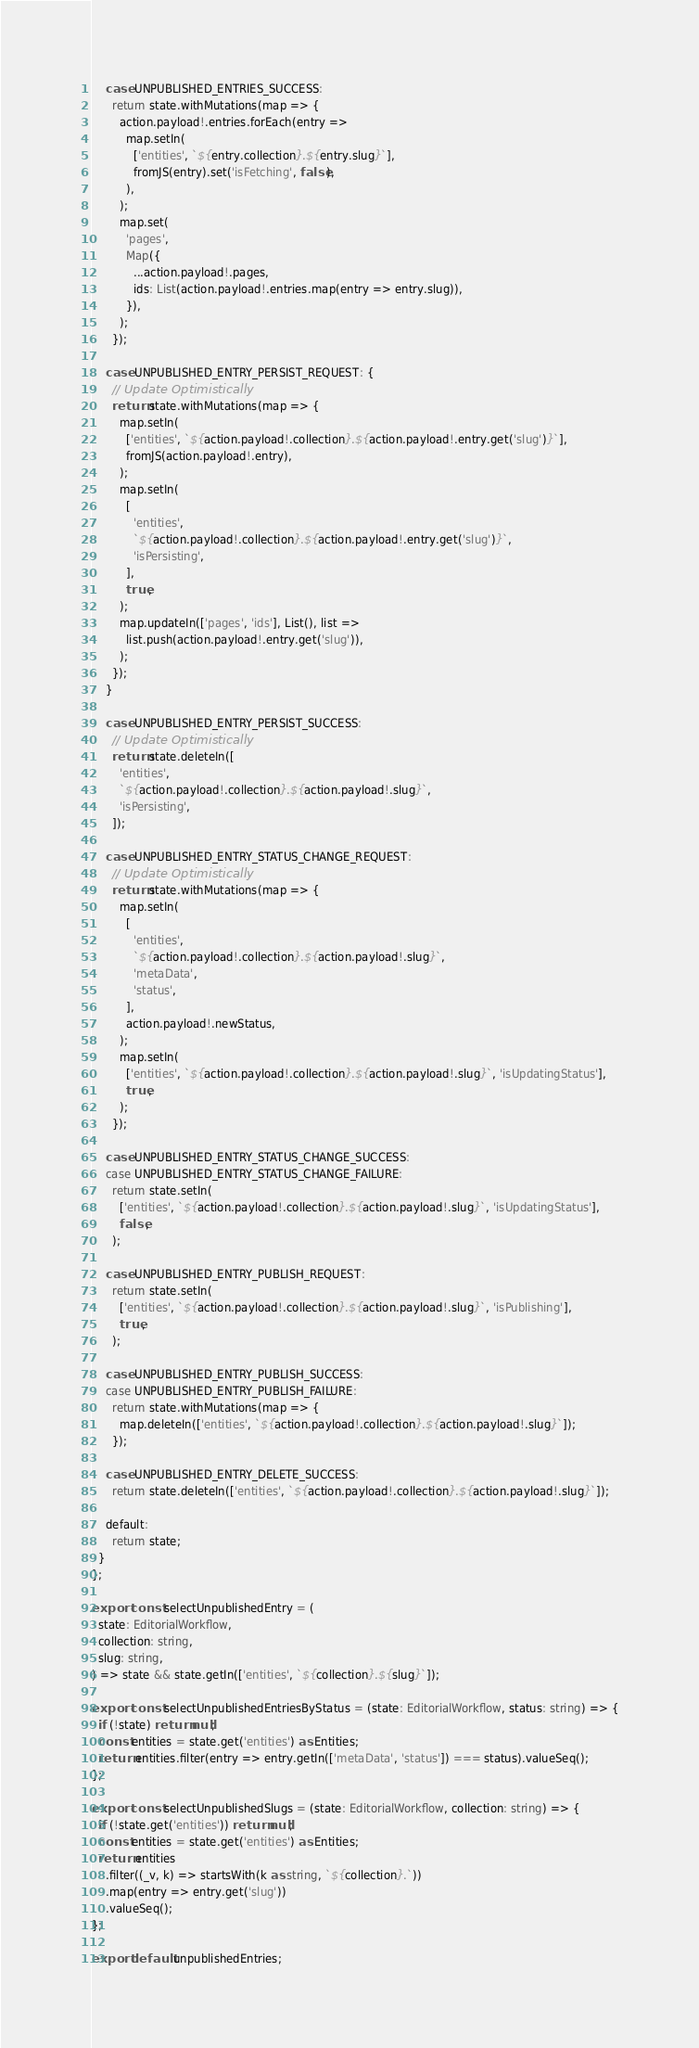Convert code to text. <code><loc_0><loc_0><loc_500><loc_500><_TypeScript_>
    case UNPUBLISHED_ENTRIES_SUCCESS:
      return state.withMutations(map => {
        action.payload!.entries.forEach(entry =>
          map.setIn(
            ['entities', `${entry.collection}.${entry.slug}`],
            fromJS(entry).set('isFetching', false),
          ),
        );
        map.set(
          'pages',
          Map({
            ...action.payload!.pages,
            ids: List(action.payload!.entries.map(entry => entry.slug)),
          }),
        );
      });

    case UNPUBLISHED_ENTRY_PERSIST_REQUEST: {
      // Update Optimistically
      return state.withMutations(map => {
        map.setIn(
          ['entities', `${action.payload!.collection}.${action.payload!.entry.get('slug')}`],
          fromJS(action.payload!.entry),
        );
        map.setIn(
          [
            'entities',
            `${action.payload!.collection}.${action.payload!.entry.get('slug')}`,
            'isPersisting',
          ],
          true,
        );
        map.updateIn(['pages', 'ids'], List(), list =>
          list.push(action.payload!.entry.get('slug')),
        );
      });
    }

    case UNPUBLISHED_ENTRY_PERSIST_SUCCESS:
      // Update Optimistically
      return state.deleteIn([
        'entities',
        `${action.payload!.collection}.${action.payload!.slug}`,
        'isPersisting',
      ]);

    case UNPUBLISHED_ENTRY_STATUS_CHANGE_REQUEST:
      // Update Optimistically
      return state.withMutations(map => {
        map.setIn(
          [
            'entities',
            `${action.payload!.collection}.${action.payload!.slug}`,
            'metaData',
            'status',
          ],
          action.payload!.newStatus,
        );
        map.setIn(
          ['entities', `${action.payload!.collection}.${action.payload!.slug}`, 'isUpdatingStatus'],
          true,
        );
      });

    case UNPUBLISHED_ENTRY_STATUS_CHANGE_SUCCESS:
    case UNPUBLISHED_ENTRY_STATUS_CHANGE_FAILURE:
      return state.setIn(
        ['entities', `${action.payload!.collection}.${action.payload!.slug}`, 'isUpdatingStatus'],
        false,
      );

    case UNPUBLISHED_ENTRY_PUBLISH_REQUEST:
      return state.setIn(
        ['entities', `${action.payload!.collection}.${action.payload!.slug}`, 'isPublishing'],
        true,
      );

    case UNPUBLISHED_ENTRY_PUBLISH_SUCCESS:
    case UNPUBLISHED_ENTRY_PUBLISH_FAILURE:
      return state.withMutations(map => {
        map.deleteIn(['entities', `${action.payload!.collection}.${action.payload!.slug}`]);
      });

    case UNPUBLISHED_ENTRY_DELETE_SUCCESS:
      return state.deleteIn(['entities', `${action.payload!.collection}.${action.payload!.slug}`]);

    default:
      return state;
  }
};

export const selectUnpublishedEntry = (
  state: EditorialWorkflow,
  collection: string,
  slug: string,
) => state && state.getIn(['entities', `${collection}.${slug}`]);

export const selectUnpublishedEntriesByStatus = (state: EditorialWorkflow, status: string) => {
  if (!state) return null;
  const entities = state.get('entities') as Entities;
  return entities.filter(entry => entry.getIn(['metaData', 'status']) === status).valueSeq();
};

export const selectUnpublishedSlugs = (state: EditorialWorkflow, collection: string) => {
  if (!state.get('entities')) return null;
  const entities = state.get('entities') as Entities;
  return entities
    .filter((_v, k) => startsWith(k as string, `${collection}.`))
    .map(entry => entry.get('slug'))
    .valueSeq();
};

export default unpublishedEntries;
</code> 